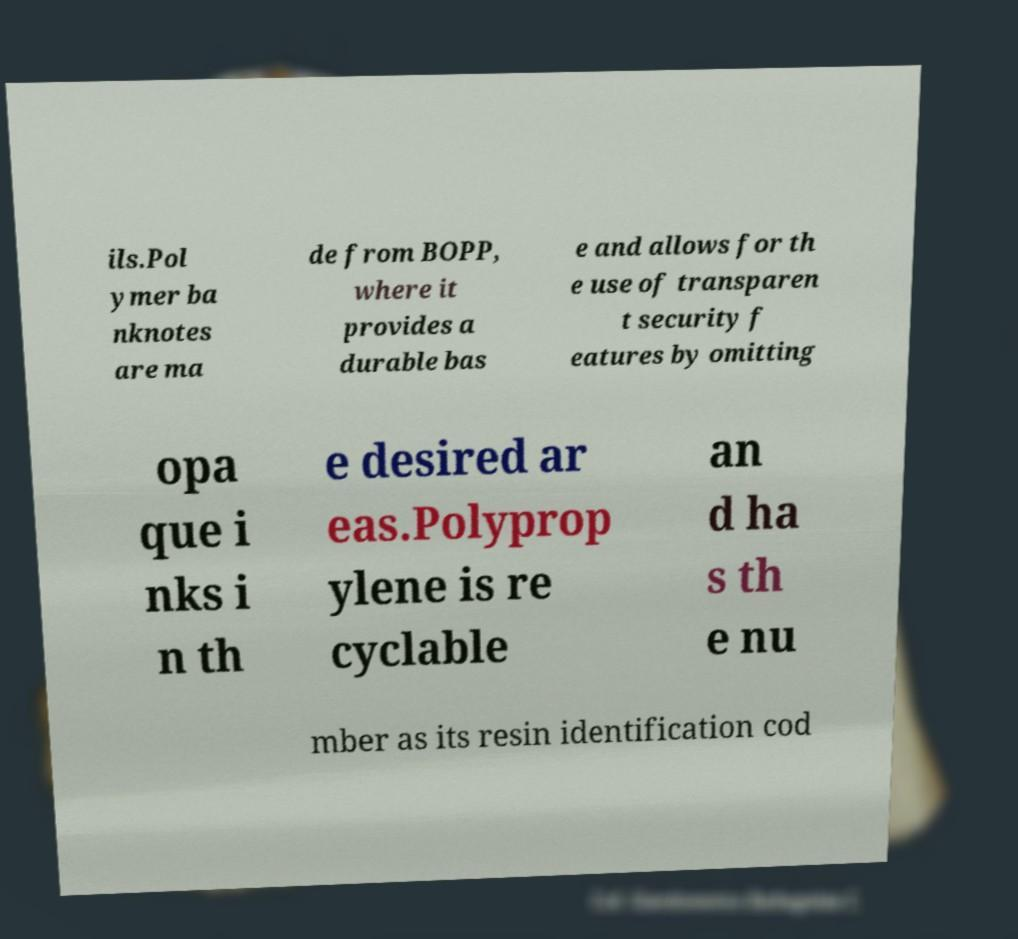What messages or text are displayed in this image? I need them in a readable, typed format. ils.Pol ymer ba nknotes are ma de from BOPP, where it provides a durable bas e and allows for th e use of transparen t security f eatures by omitting opa que i nks i n th e desired ar eas.Polyprop ylene is re cyclable an d ha s th e nu mber as its resin identification cod 